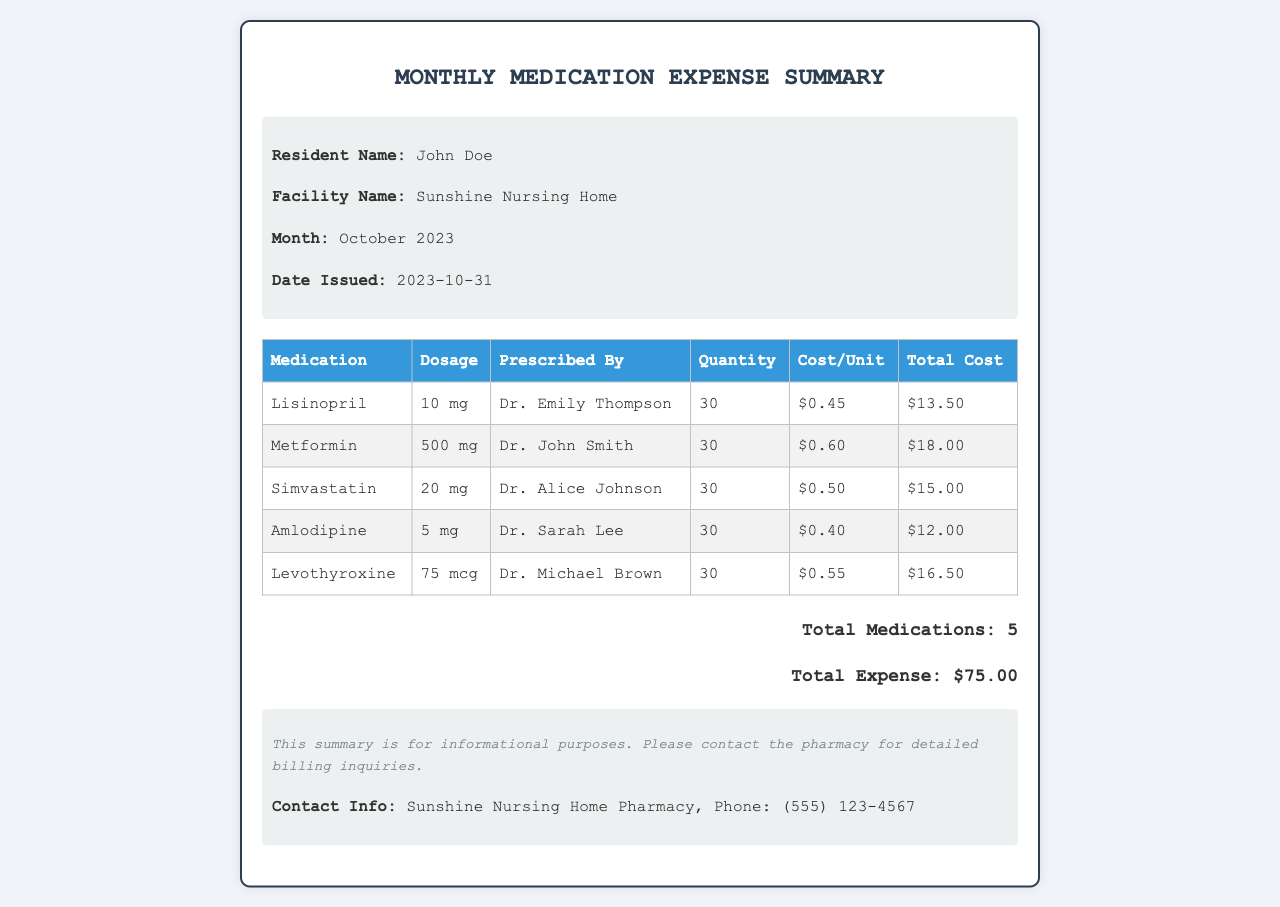What is the resident's name? The resident's name is listed in the document header section.
Answer: John Doe Who prescribed Metformin? The name of the doctor who prescribed Metformin is mentioned in the relevant table row.
Answer: Dr. John Smith What is the total expense for medications? The total expense is summarized at the end of the document.
Answer: $75.00 How many medications are listed? The total number of medications is provided in the summary section of the document.
Answer: 5 What is the cost per unit of Simvastatin? The cost per unit of Simvastatin is found in the respective row of the table.
Answer: $0.50 What dosage of Amlodipine is prescribed? The dosage for Amlodipine is specified in the table under the dosage column.
Answer: 5 mg Which facility is this expense summary for? The facility name is noted in the header section of the document.
Answer: Sunshine Nursing Home When was this document issued? The date issued is mentioned prominently in the header section.
Answer: 2023-10-31 